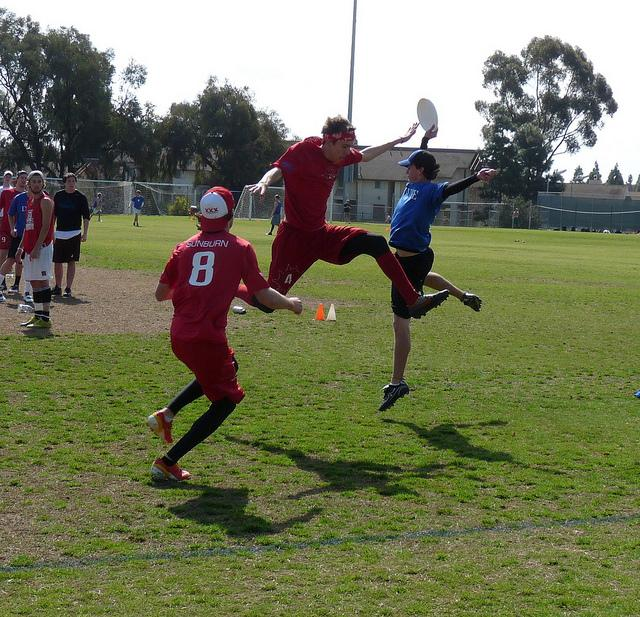What word rhymes with the number on the man's shirt? great 